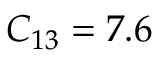<formula> <loc_0><loc_0><loc_500><loc_500>C _ { 1 3 } = 7 . 6</formula> 